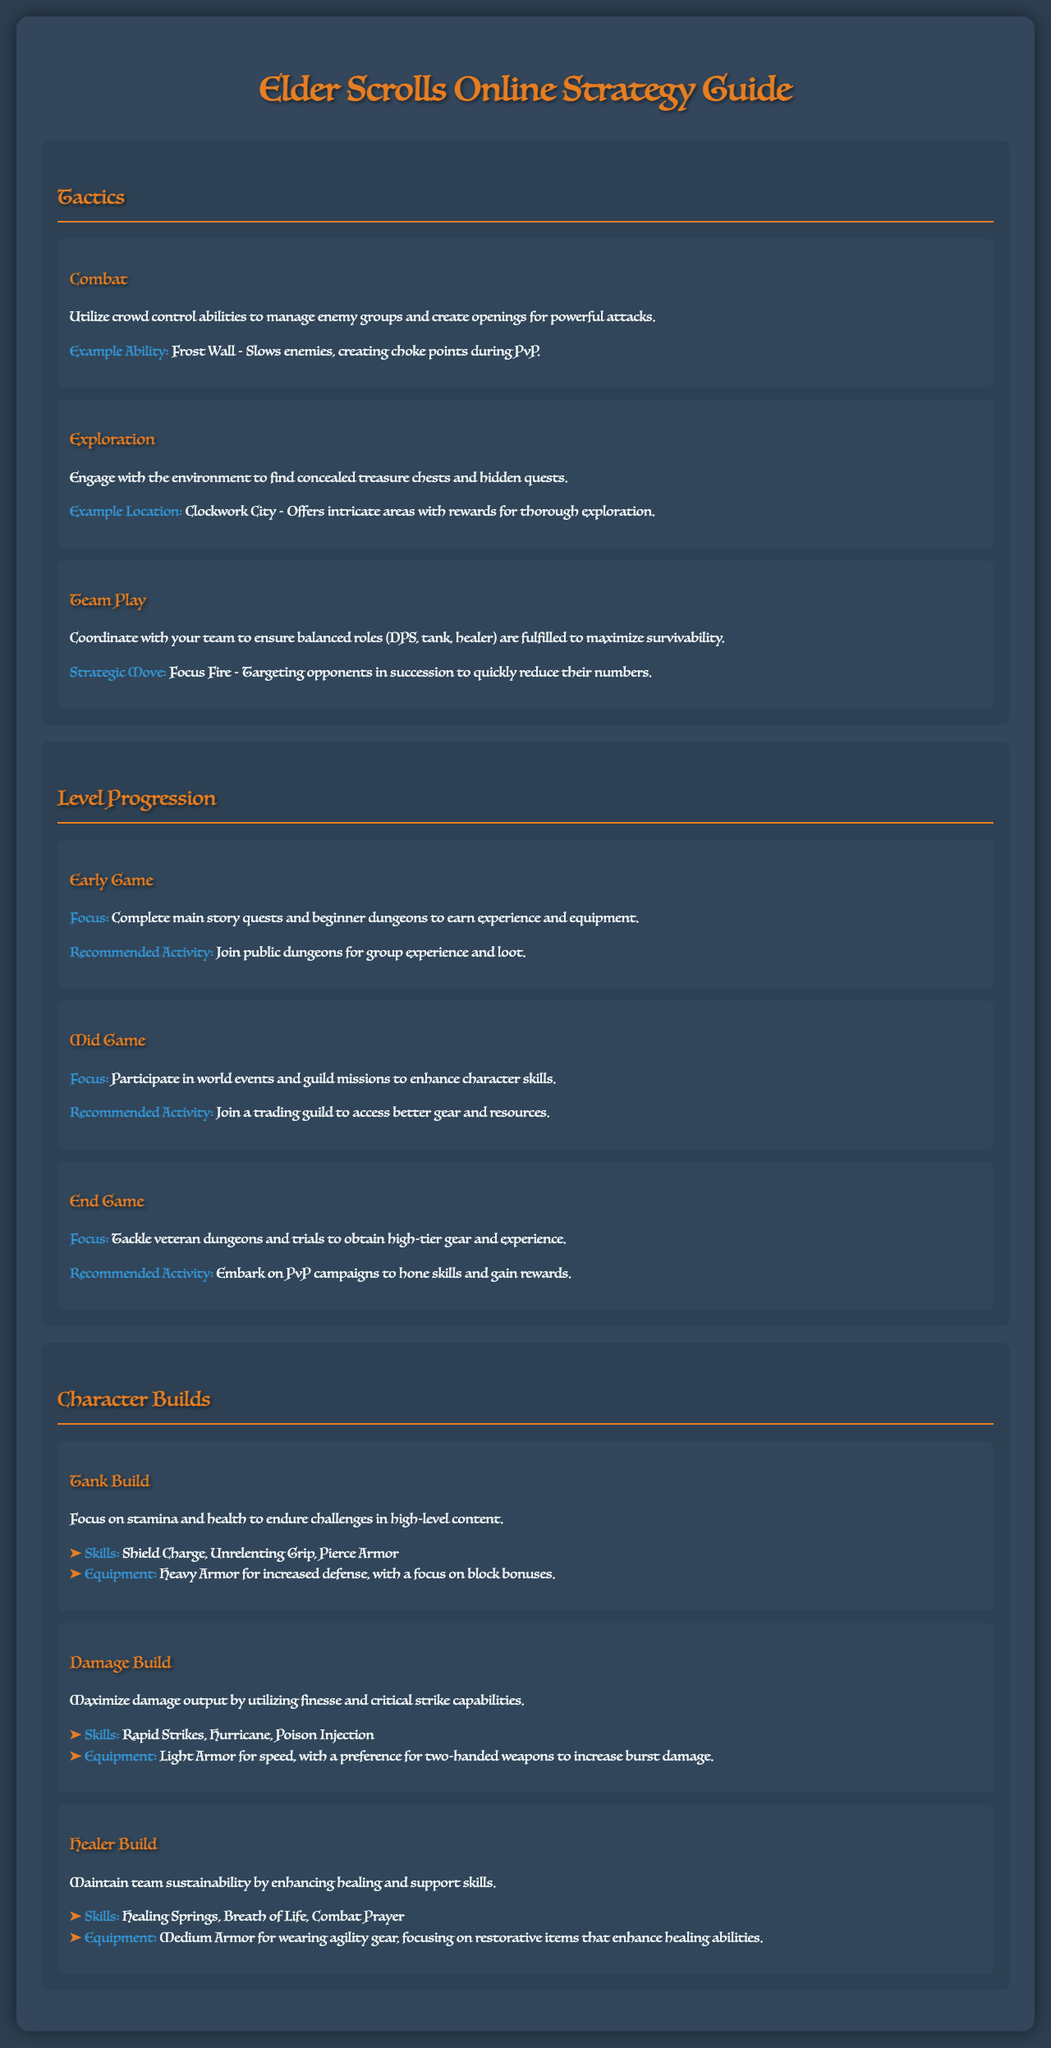What is the main focus of the early game? The main focus of the early game is to complete main story quests and beginner dungeons to earn experience and equipment.
Answer: Complete main story quests and beginner dungeons What ability is mentioned for crowd control? The document mentions Frost Wall as an ability for crowd control.
Answer: Frost Wall What are the recommended skills for the Tank Build? The recommended skills for the Tank Build are Shield Charge, Unrelenting Grip, and Pierce Armor.
Answer: Shield Charge, Unrelenting Grip, Pierce Armor What is the strategic move highlighted for team play? The strategic move highlighted for team play is Focus Fire.
Answer: Focus Fire Which location is suggested for exploration? The suggested location for exploration is Clockwork City.
Answer: Clockwork City What type of armor should be used for the Damage Build? For the Damage Build, Light Armor should be used.
Answer: Light Armor What is the focus of mid-game progression? The focus of mid-game progression is to participate in world events and guild missions.
Answer: Participate in world events and guild missions What equipment is recommended for the Healer Build? The recommended equipment for the Healer Build is Medium Armor.
Answer: Medium Armor What activity is recommended for the End Game? The recommended activity for the End Game is to tackle veteran dungeons and trials.
Answer: Tackle veteran dungeons and trials 